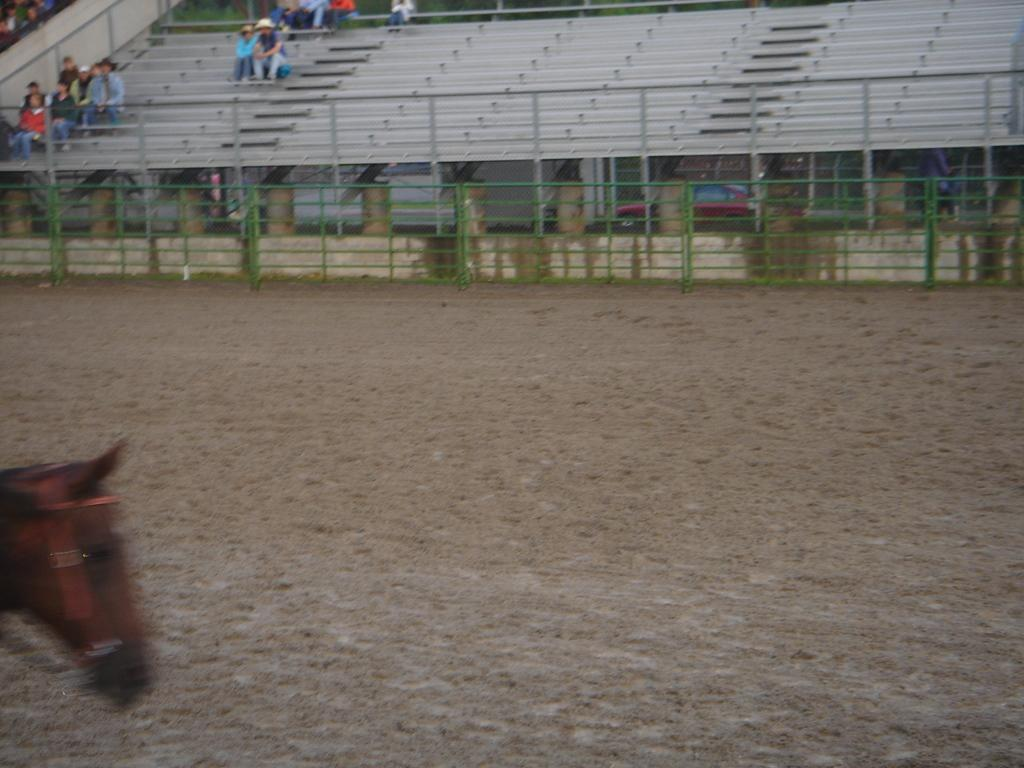What animal is on the ground in the image? There is a horse on the ground in the image. What can be seen separating the horse from the vehicles on the road? There is a fence in the image. What type of transportation can be seen on the road in the image? There are vehicles on the road in the image. Where are the people in the image located? There is a group of people sitting in a stadium in the image. What material is used for the rods in the image? Metal rods are present in the image. From what perspective is the image taken? The image appears to be taken from the ground level. What type of verse can be seen recited by the fish in the image? There are no fish or verses present in the image. What stage of development is the horse in the image? The image does not provide information about the horse's development stage. 